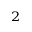<formula> <loc_0><loc_0><loc_500><loc_500>^ { 2 }</formula> 